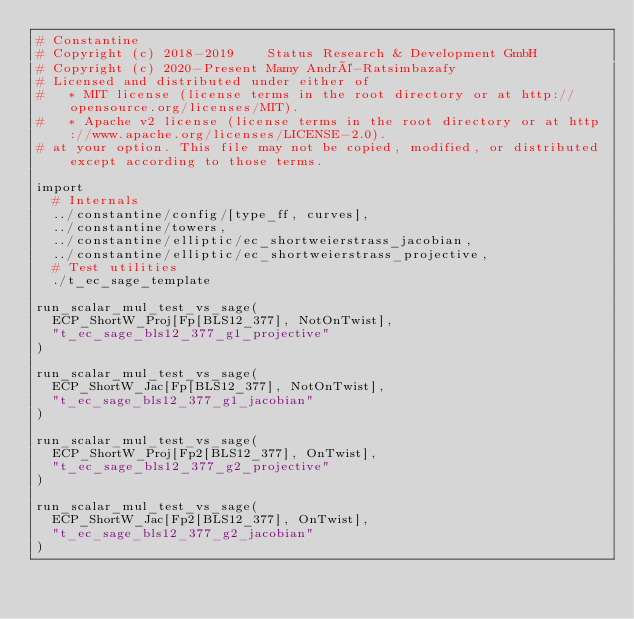<code> <loc_0><loc_0><loc_500><loc_500><_Nim_># Constantine
# Copyright (c) 2018-2019    Status Research & Development GmbH
# Copyright (c) 2020-Present Mamy André-Ratsimbazafy
# Licensed and distributed under either of
#   * MIT license (license terms in the root directory or at http://opensource.org/licenses/MIT).
#   * Apache v2 license (license terms in the root directory or at http://www.apache.org/licenses/LICENSE-2.0).
# at your option. This file may not be copied, modified, or distributed except according to those terms.

import
  # Internals
  ../constantine/config/[type_ff, curves],
  ../constantine/towers,
  ../constantine/elliptic/ec_shortweierstrass_jacobian,
  ../constantine/elliptic/ec_shortweierstrass_projective,
  # Test utilities
  ./t_ec_sage_template

run_scalar_mul_test_vs_sage(
  ECP_ShortW_Proj[Fp[BLS12_377], NotOnTwist],
  "t_ec_sage_bls12_377_g1_projective"
)

run_scalar_mul_test_vs_sage(
  ECP_ShortW_Jac[Fp[BLS12_377], NotOnTwist],
  "t_ec_sage_bls12_377_g1_jacobian"
)

run_scalar_mul_test_vs_sage(
  ECP_ShortW_Proj[Fp2[BLS12_377], OnTwist],
  "t_ec_sage_bls12_377_g2_projective"
)

run_scalar_mul_test_vs_sage(
  ECP_ShortW_Jac[Fp2[BLS12_377], OnTwist],
  "t_ec_sage_bls12_377_g2_jacobian"
)
</code> 